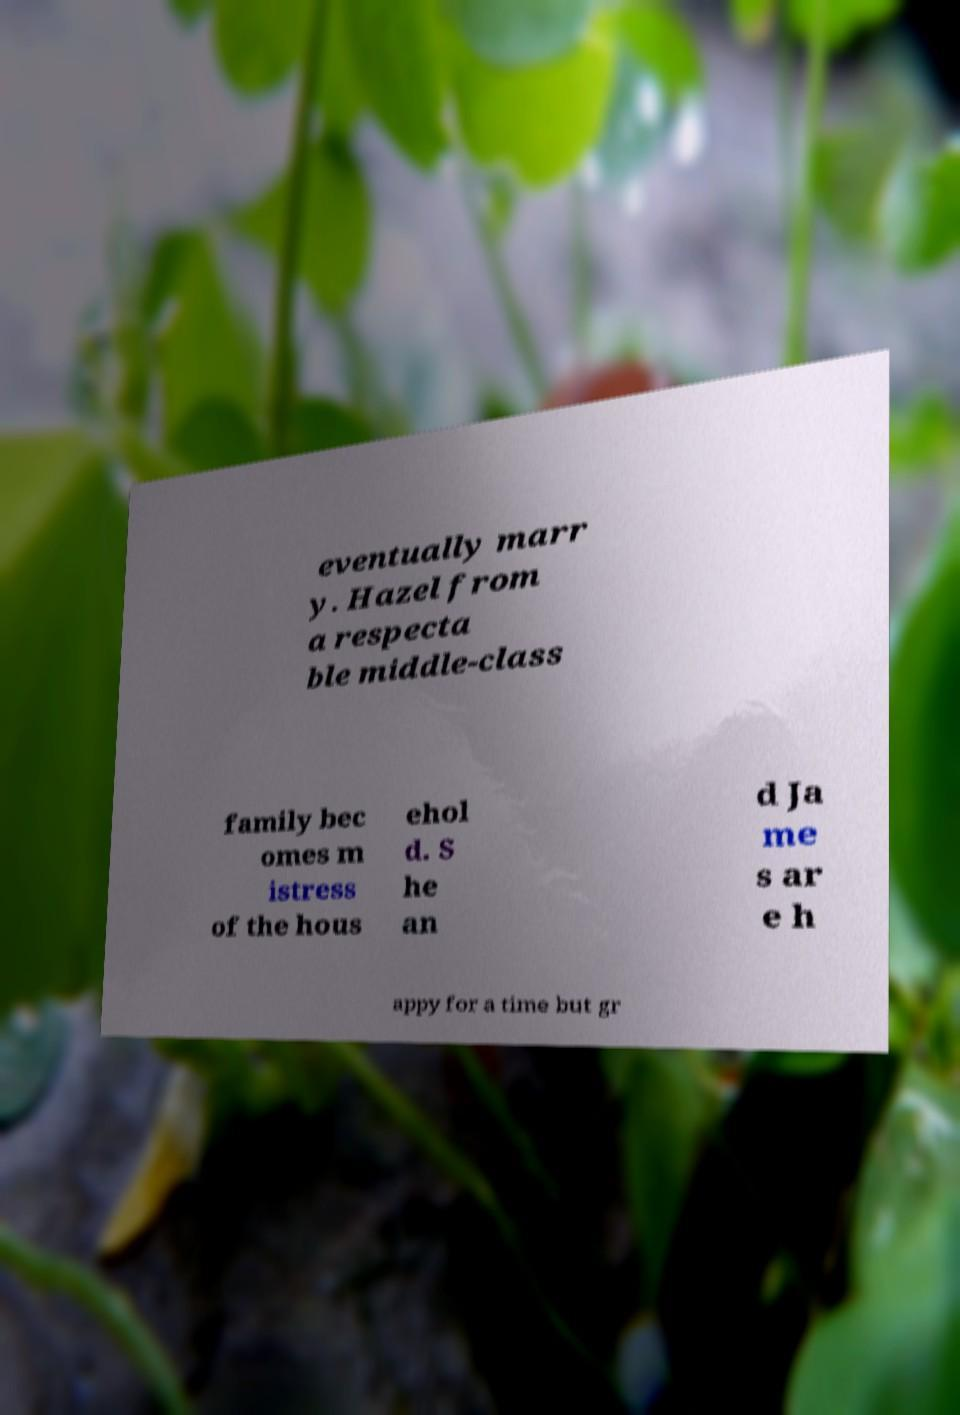What messages or text are displayed in this image? I need them in a readable, typed format. eventually marr y. Hazel from a respecta ble middle-class family bec omes m istress of the hous ehol d. S he an d Ja me s ar e h appy for a time but gr 